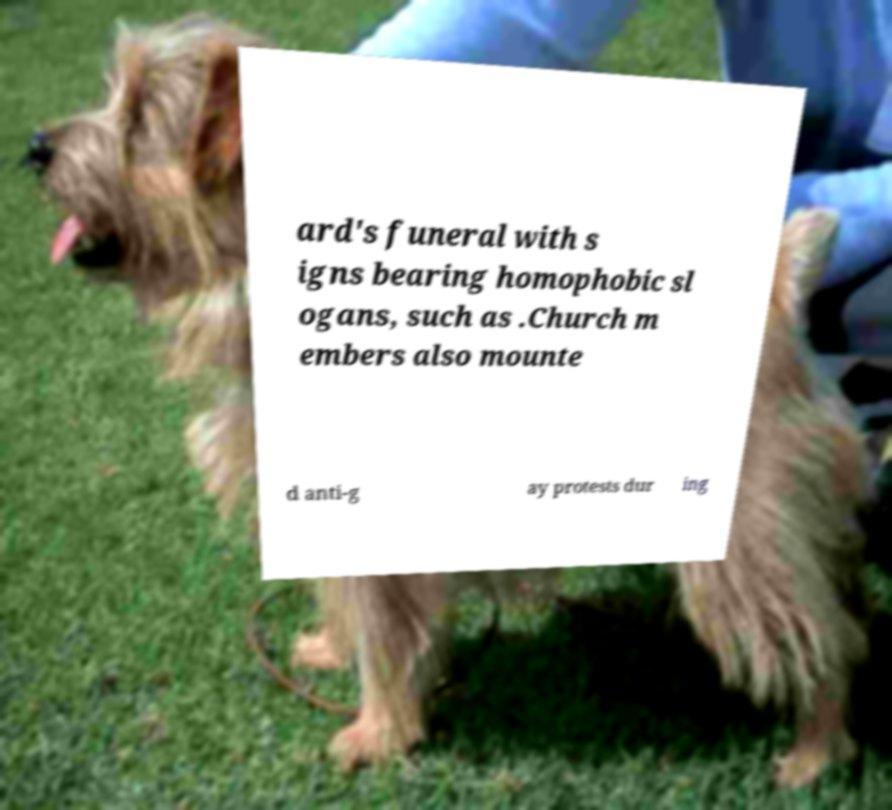Could you assist in decoding the text presented in this image and type it out clearly? ard's funeral with s igns bearing homophobic sl ogans, such as .Church m embers also mounte d anti-g ay protests dur ing 